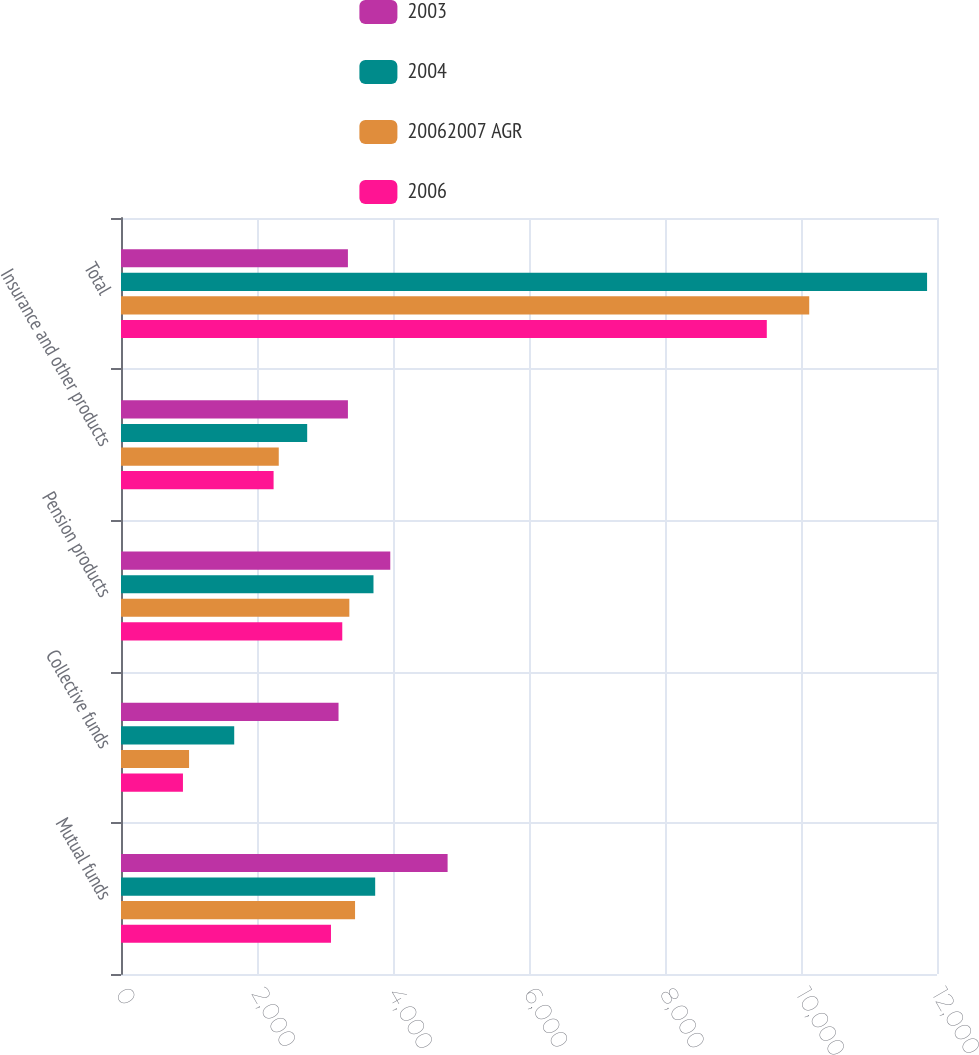Convert chart to OTSL. <chart><loc_0><loc_0><loc_500><loc_500><stacked_bar_chart><ecel><fcel>Mutual funds<fcel>Collective funds<fcel>Pension products<fcel>Insurance and other products<fcel>Total<nl><fcel>2003<fcel>4803<fcel>3199<fcel>3960<fcel>3337<fcel>3337<nl><fcel>2004<fcel>3738<fcel>1665<fcel>3713<fcel>2738<fcel>11854<nl><fcel>20062007 AGR<fcel>3442<fcel>1001<fcel>3358<fcel>2320<fcel>10121<nl><fcel>2006<fcel>3088<fcel>911<fcel>3254<fcel>2244<fcel>9497<nl></chart> 